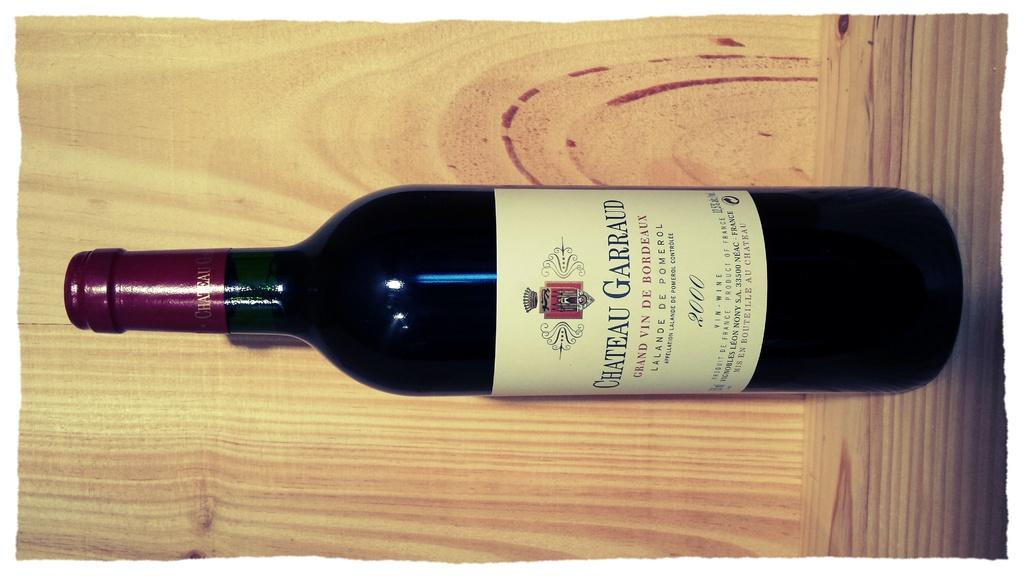<image>
Create a compact narrative representing the image presented. A sealed bottle of Chateau Garraud Grand Vin De Bordeaux is standing in a wooden display. 